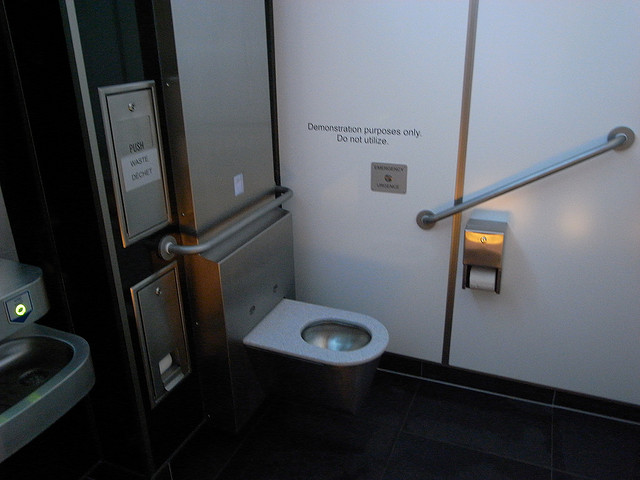<image>What kind of picture are on the wall? It's uncertain what kind of picture is on the wall as there seems to be no picture provided in the image. However, there could be signs or instructions. What kind of picture are on the wall? There are signs and instructions on the wall. 